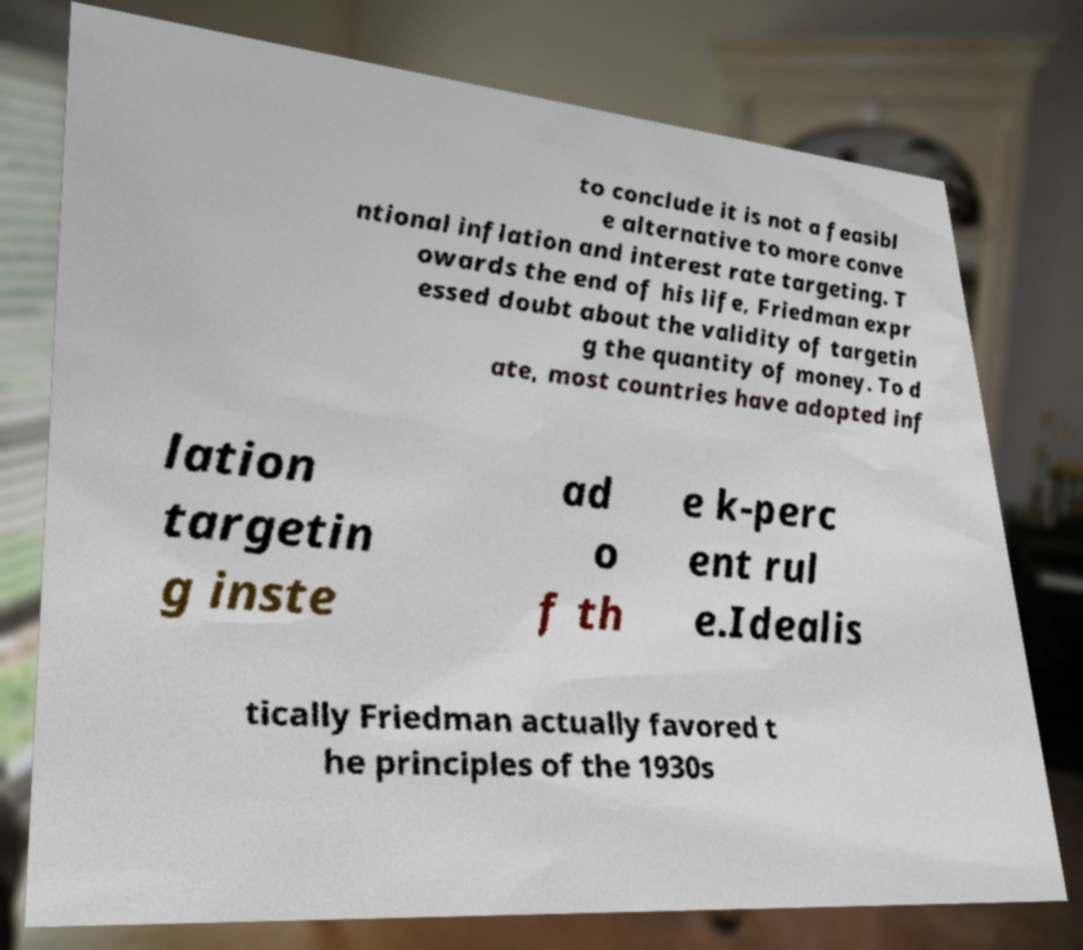Please read and relay the text visible in this image. What does it say? to conclude it is not a feasibl e alternative to more conve ntional inflation and interest rate targeting. T owards the end of his life, Friedman expr essed doubt about the validity of targetin g the quantity of money. To d ate, most countries have adopted inf lation targetin g inste ad o f th e k-perc ent rul e.Idealis tically Friedman actually favored t he principles of the 1930s 